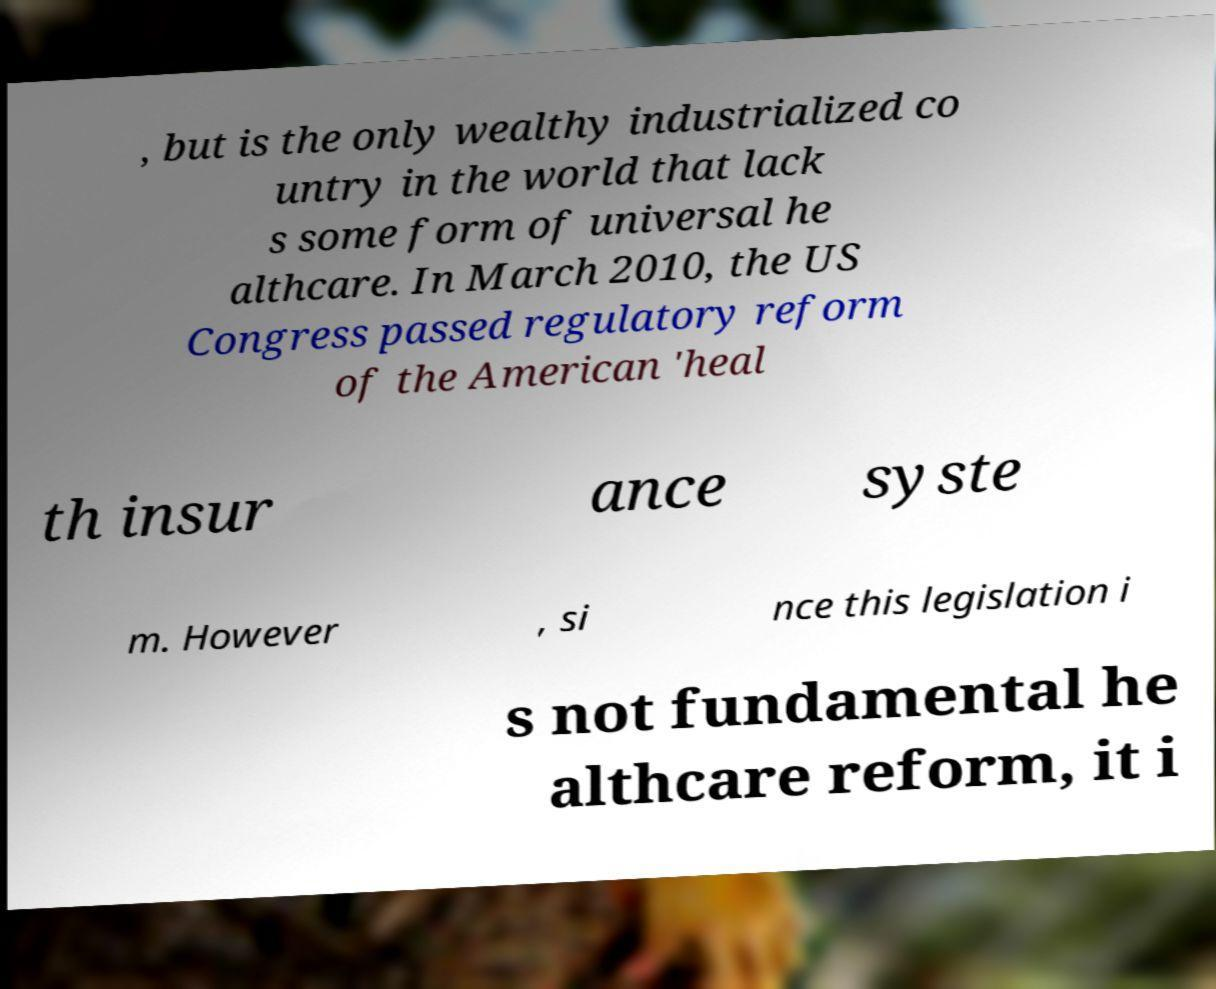Please read and relay the text visible in this image. What does it say? , but is the only wealthy industrialized co untry in the world that lack s some form of universal he althcare. In March 2010, the US Congress passed regulatory reform of the American 'heal th insur ance syste m. However , si nce this legislation i s not fundamental he althcare reform, it i 